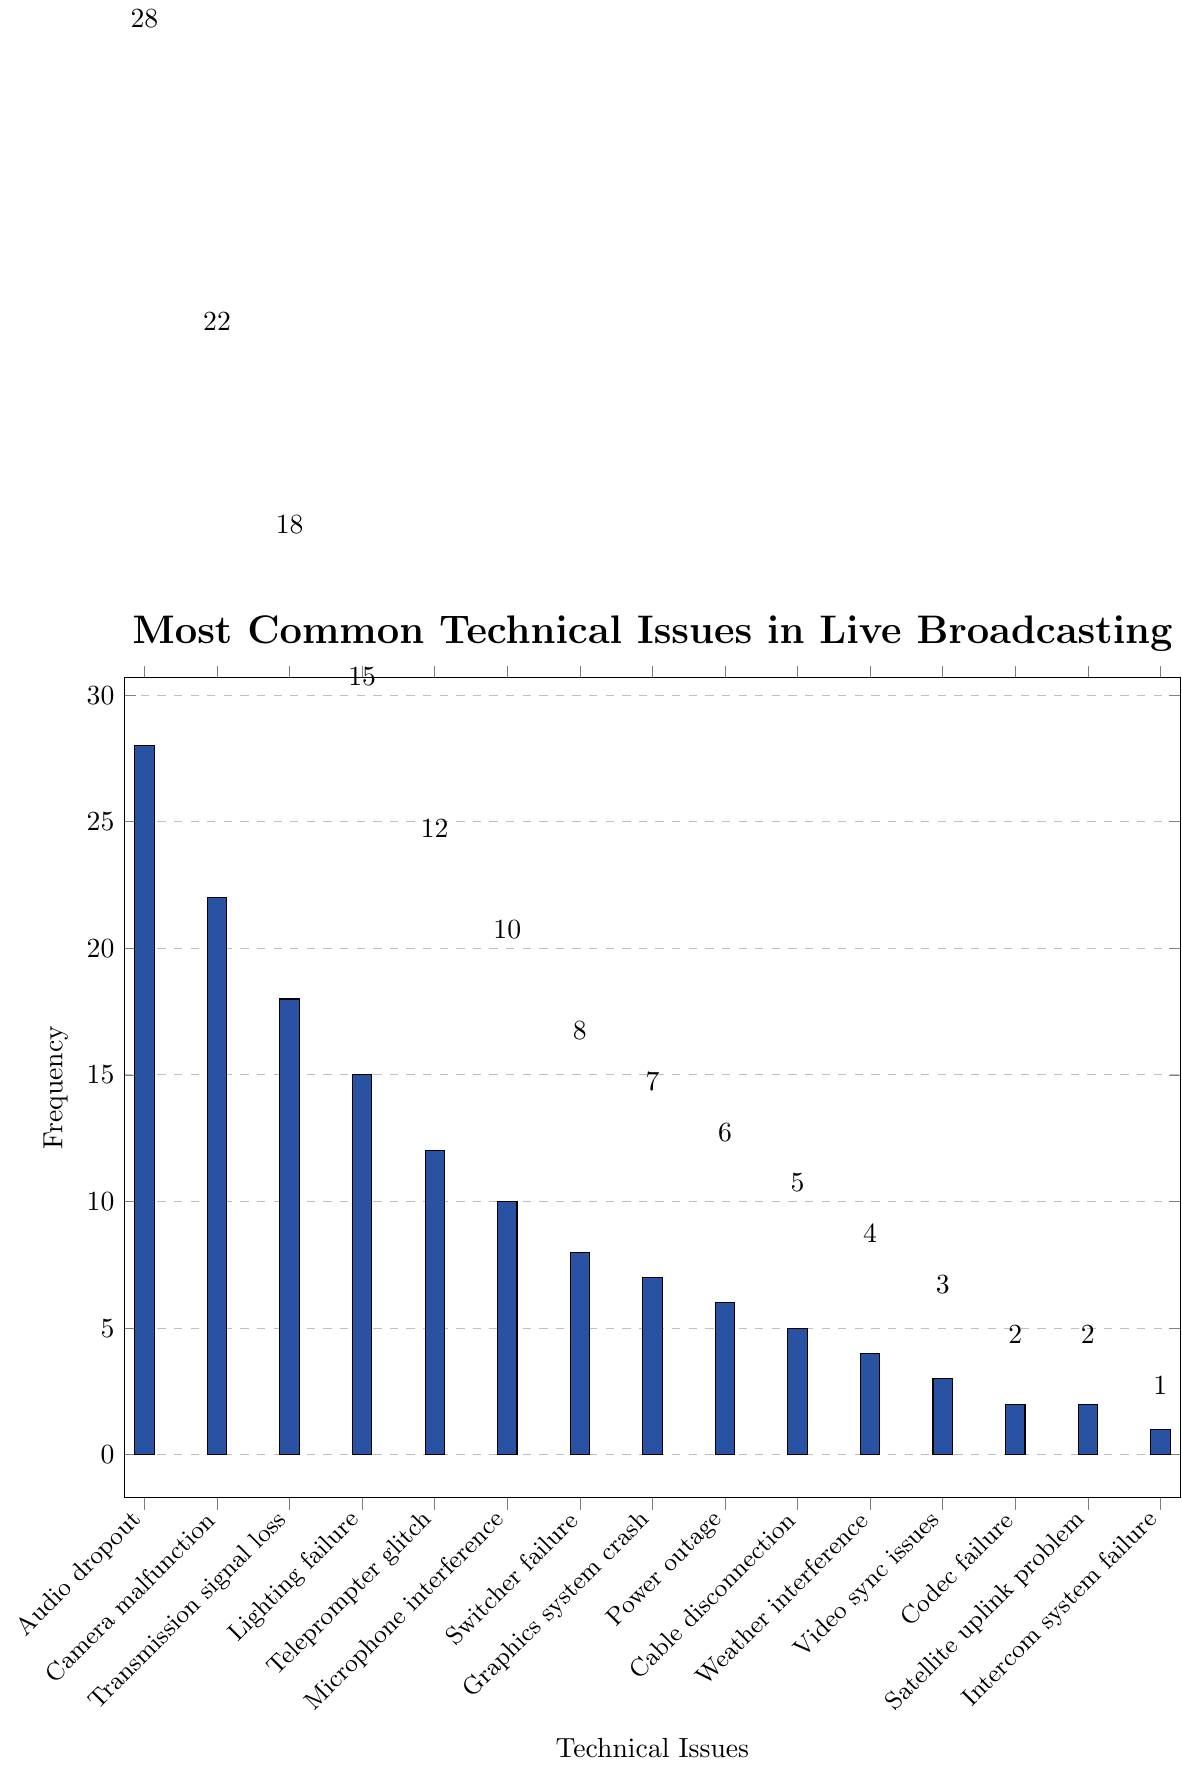Which technical issue has the highest frequency? From the figure, the bar representing "Audio dropout" is the tallest, indicating it has the highest frequency.
Answer: Audio dropout Which technical issue occurs less frequently, "Teleprompter glitch" or "Graphics system crash"? The bar for "Graphics system crash" is shorter than the bar for "Teleprompter glitch," indicating it occurs less frequently.
Answer: Graphics system crash What is the combined frequency of "Transmission signal loss" and "Lighting failure"? From the figure, "Transmission signal loss" has a frequency of 18 and "Lighting failure" has a frequency of 15. Adding these values gives 18 + 15 = 33.
Answer: 33 How many more times does "Camera malfunction" occur compared to "Microphone interference"? "Camera malfunction" occurs 22 times and "Microphone interference" occurs 10 times. The difference is 22 - 10 = 12.
Answer: 12 Which issue has the least frequency, and what is its value? The shortest bar represents "Intercom system failure," indicating it has the least frequency. The frequency is 1.
Answer: Intercom system failure, 1 Compare the frequencies of "Power outage" and "Cable disconnection". Which is higher and by how much? "Power outage" has a frequency of 6, while "Cable disconnection" has a frequency of 5. The difference is 6 - 5 = 1.
Answer: Power outage by 1 Calculate the average frequency of the top three most common issues. The top three issues are "Audio dropout" (28), "Camera malfunction" (22), and "Transmission signal loss" (18). The average is (28 + 22 + 18) / 3 = 68 / 3 ≈ 22.67.
Answer: 22.67 Which issue has a frequency equal to the median frequency among all listed issues? To find the median, list the frequencies in ascending order: 1, 2, 2, 3, 4, 5, 6, 7, 8, 10, 12, 15, 18, 22, 28. The middle value (eighth value) is 7, which corresponds to the "Graphics system crash" issue.
Answer: Graphics system crash How many issues have a frequency of 10 or more? From the figure, the issues with frequencies 10 or more are: "Audio dropout" (28), "Camera malfunction" (22), "Transmission signal loss" (18), "Lighting failure" (15), "Teleprompter glitch" (12) and "Microphone interference" (10). There are 6 such issues.
Answer: 6 